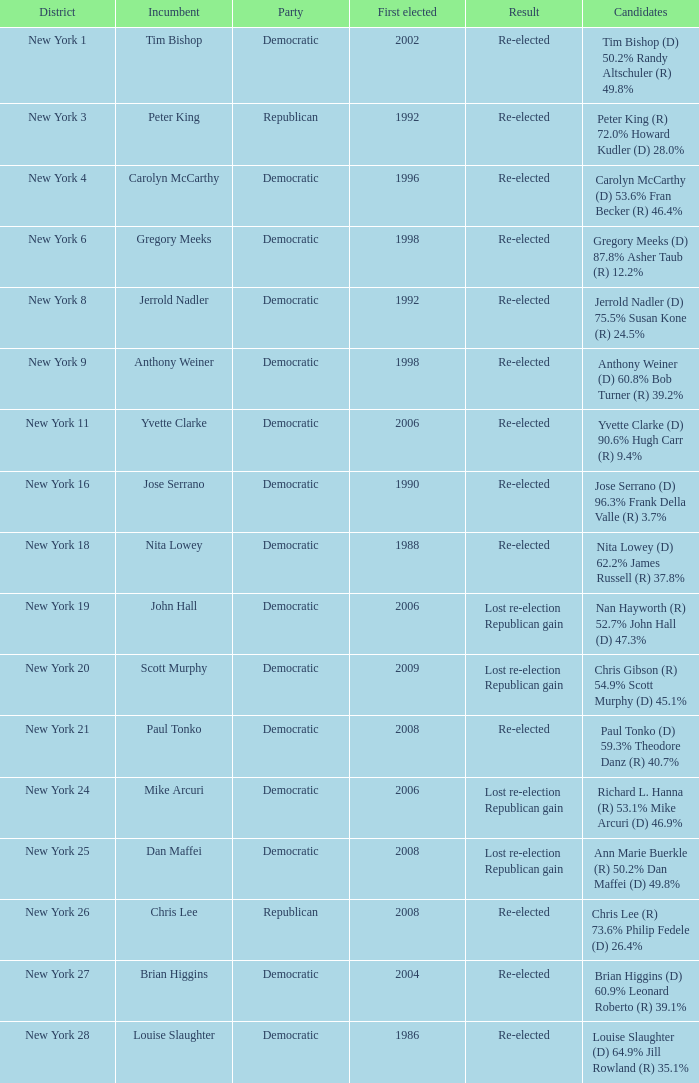Name the number of party for richard l. hanna (r) 53.1% mike arcuri (d) 46.9% 1.0. 